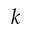<formula> <loc_0><loc_0><loc_500><loc_500>k</formula> 